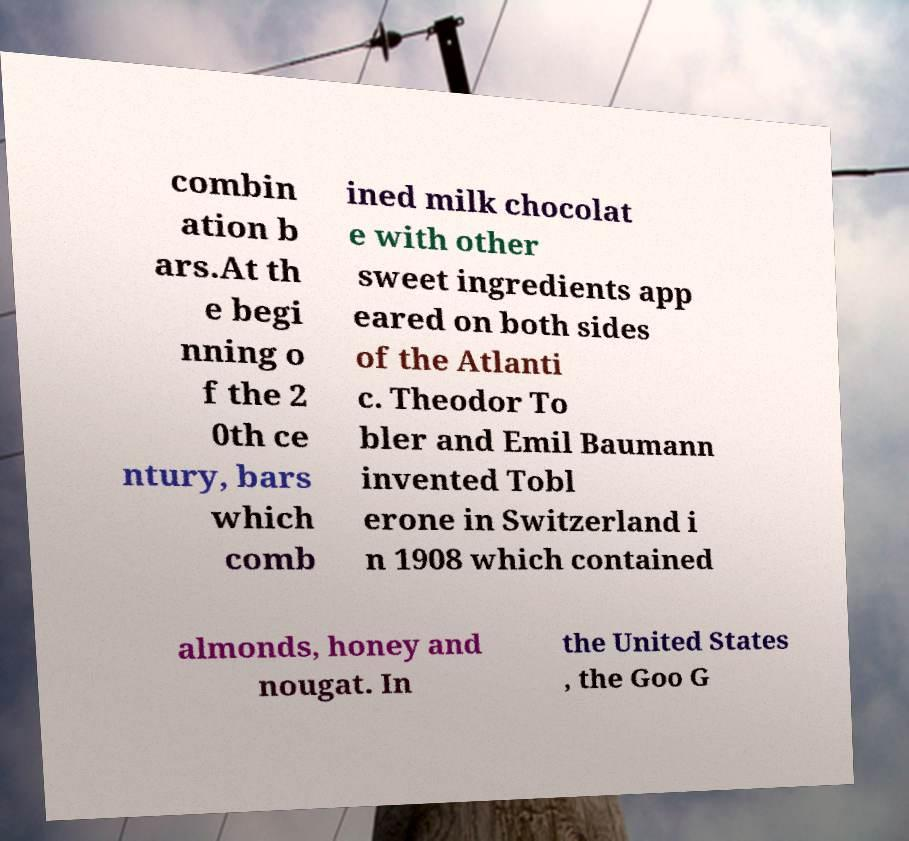For documentation purposes, I need the text within this image transcribed. Could you provide that? combin ation b ars.At th e begi nning o f the 2 0th ce ntury, bars which comb ined milk chocolat e with other sweet ingredients app eared on both sides of the Atlanti c. Theodor To bler and Emil Baumann invented Tobl erone in Switzerland i n 1908 which contained almonds, honey and nougat. In the United States , the Goo G 